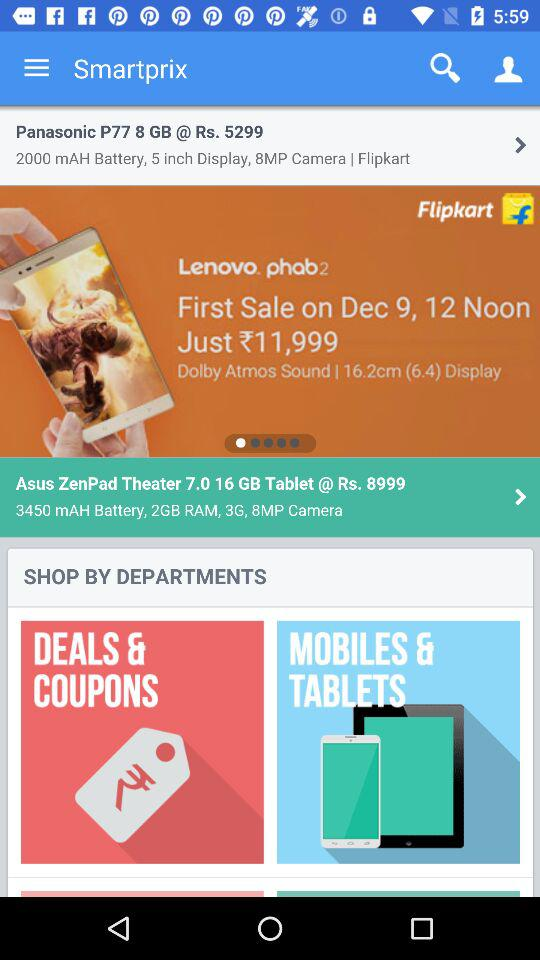What is the price of the Panasonic P77? The price of the Panasonic P77 is Rs. 5299. 